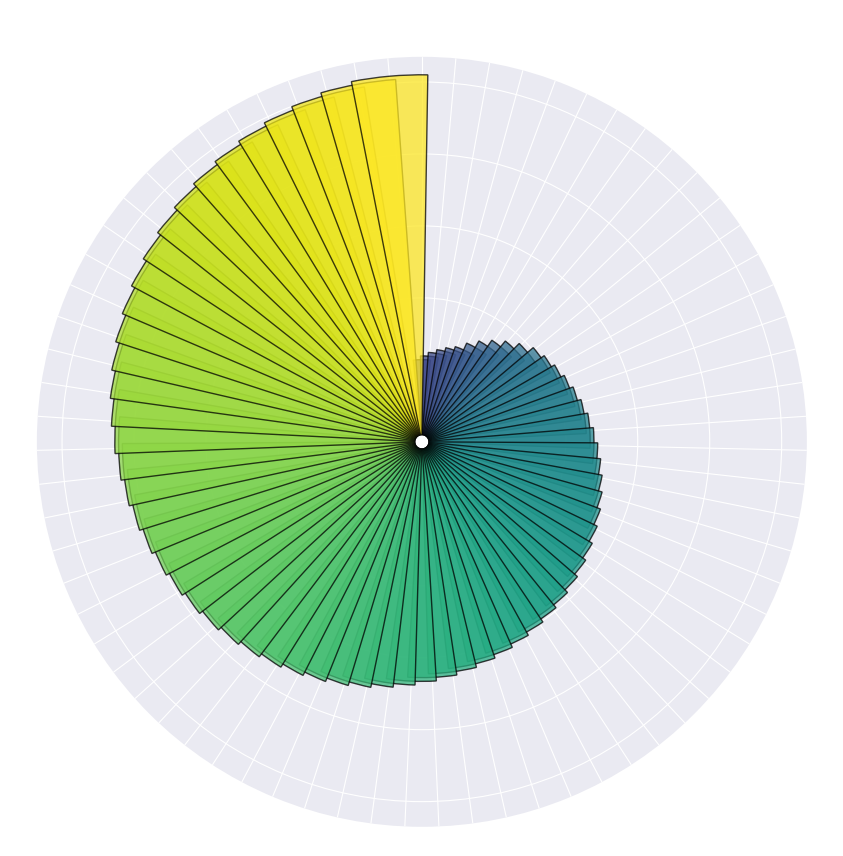What decade shows the highest overall adoption rates? To identify the highest overall adoption rates by decade, observe the length of bars in each grouping of ten years. The 2010s show the highest overall adoption rates as the bars representing those years are the tallest.
Answer: 2010s How do the adoption rates in 1950 compare to those in 2020? Compare the lengths of the bars at 1950 and 2020. The bar for 2020 is much longer than the bar for 1950, indicating significantly higher adoption rates.
Answer: Higher in 2020 What is the trend in adoption rates from 1950 to 1980? Observe the bars from 1950 to 1980. The bars steadily increase in length, showing a consistent rise in adoption rates during this period.
Answer: Increasing Around what year did adoption rates first exceed 60,000? Identify the first bar that appears longer than the 60,000 level. Based on the plot, this occurs around 1985.
Answer: 1985 Which year marks the beginning of a significant rise in adoption rates after 2000? Look at the bars after the year 2000 for a noticeable increase in height. The significant rise can be seen starting around 2010.
Answer: 2010 What can you infer about the adoption rates in the 1970s compared to the 1960s? Compare the bars in the 1970s to those in the 1960s. Adoption rates are generally higher in the 1970s as the bars are noticeably longer.
Answer: Higher in 1970s Which year had the lowest adoption rate, and how does it visually compare to the peak year? The year 1950 has the shortest bar, indicating the lowest adoption rate. Visually, it is much shorter than the peak year 2020, which has the longest bar.
Answer: 1950, significantly shorter than 2020 Are there any years where adoption rates decreased compared to the previous year? Scan the lengths of consecutive bars for any noticeable decreases. There do not appear to be any years where the adoption rates are visibly lower than the previous year.
Answer: No What is the approximate difference in adoption rates between 1970 and 1990? Compare the bar lengths for 1970 and 1990. The difference between the heights indicates an approximate increase in adoption rates from 46,000 in 1970 to 66,000 in 1990, about 20,000.
Answer: 20,000 Is there a decade where adoption rates appear to plateau? Observe the length of bars within each decade to identify any consistent heights. The 1980s exhibit a plateau with relatively steady adoption rates around the 60,000 mark.
Answer: 1980s 